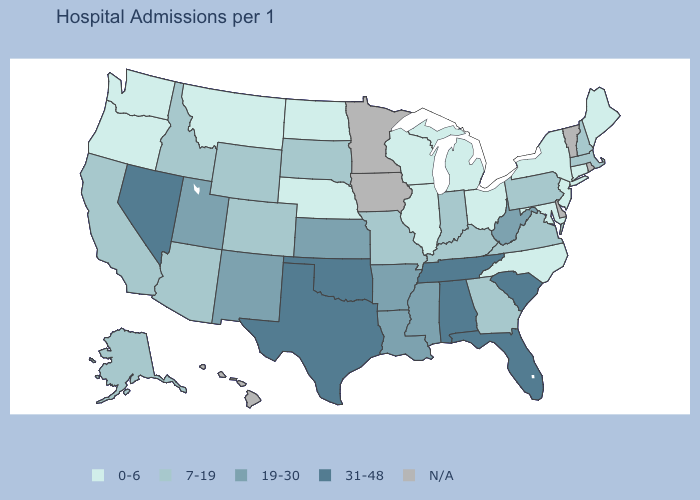Does West Virginia have the highest value in the South?
Quick response, please. No. Does the map have missing data?
Give a very brief answer. Yes. What is the value of Oklahoma?
Concise answer only. 31-48. Which states have the highest value in the USA?
Quick response, please. Alabama, Florida, Nevada, Oklahoma, South Carolina, Tennessee, Texas. Name the states that have a value in the range N/A?
Concise answer only. Delaware, Hawaii, Iowa, Minnesota, Rhode Island, Vermont. Which states have the highest value in the USA?
Answer briefly. Alabama, Florida, Nevada, Oklahoma, South Carolina, Tennessee, Texas. Among the states that border Louisiana , which have the highest value?
Be succinct. Texas. Among the states that border Michigan , which have the highest value?
Give a very brief answer. Indiana. What is the highest value in states that border Illinois?
Answer briefly. 7-19. Name the states that have a value in the range 7-19?
Be succinct. Alaska, Arizona, California, Colorado, Georgia, Idaho, Indiana, Kentucky, Massachusetts, Missouri, New Hampshire, Pennsylvania, South Dakota, Virginia, Wyoming. What is the value of Missouri?
Concise answer only. 7-19. Name the states that have a value in the range 0-6?
Be succinct. Connecticut, Illinois, Maine, Maryland, Michigan, Montana, Nebraska, New Jersey, New York, North Carolina, North Dakota, Ohio, Oregon, Washington, Wisconsin. Does the map have missing data?
Be succinct. Yes. 